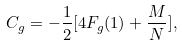Convert formula to latex. <formula><loc_0><loc_0><loc_500><loc_500>C _ { g } = - \frac { 1 } { 2 } [ 4 F _ { g } ( 1 ) + \frac { M } { N } ] ,</formula> 